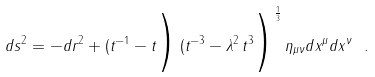Convert formula to latex. <formula><loc_0><loc_0><loc_500><loc_500>d s ^ { 2 } = - d r ^ { 2 } + ( t ^ { - 1 } - t \Big ) \, ( t ^ { - 3 } - \lambda ^ { 2 } \, t ^ { 3 } \Big ) ^ { \frac { 1 } { 3 } } \, \eta _ { \mu \nu } d x ^ { \mu } d x ^ { \nu } \ .</formula> 